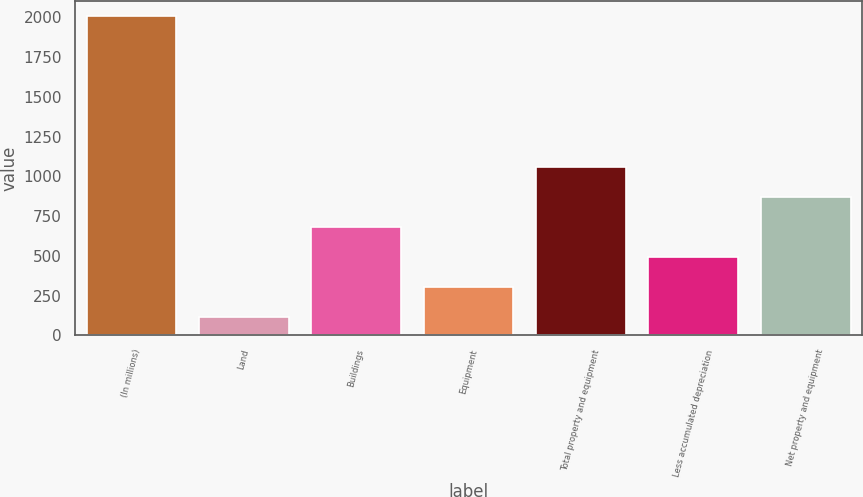Convert chart. <chart><loc_0><loc_0><loc_500><loc_500><bar_chart><fcel>(In millions)<fcel>Land<fcel>Buildings<fcel>Equipment<fcel>Total property and equipment<fcel>Less accumulated depreciation<fcel>Net property and equipment<nl><fcel>2006<fcel>118<fcel>684.4<fcel>306.8<fcel>1062<fcel>495.6<fcel>873.2<nl></chart> 